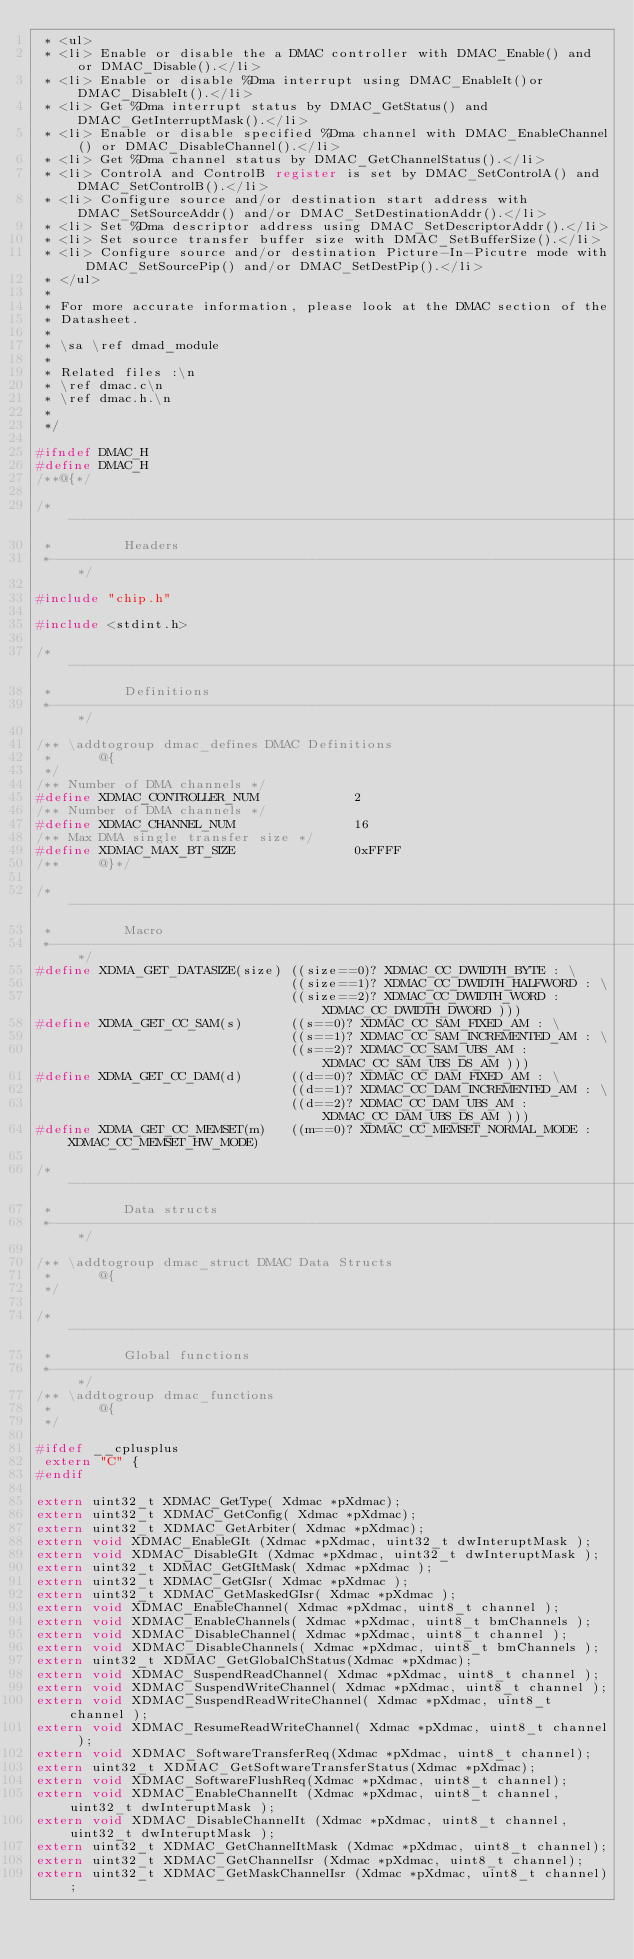Convert code to text. <code><loc_0><loc_0><loc_500><loc_500><_C_> * <ul>
 * <li> Enable or disable the a DMAC controller with DMAC_Enable() and or DMAC_Disable().</li>
 * <li> Enable or disable %Dma interrupt using DMAC_EnableIt()or DMAC_DisableIt().</li>
 * <li> Get %Dma interrupt status by DMAC_GetStatus() and DMAC_GetInterruptMask().</li>
 * <li> Enable or disable specified %Dma channel with DMAC_EnableChannel() or DMAC_DisableChannel().</li>
 * <li> Get %Dma channel status by DMAC_GetChannelStatus().</li>
 * <li> ControlA and ControlB register is set by DMAC_SetControlA() and DMAC_SetControlB().</li>
 * <li> Configure source and/or destination start address with DMAC_SetSourceAddr() and/or DMAC_SetDestinationAddr().</li>
 * <li> Set %Dma descriptor address using DMAC_SetDescriptorAddr().</li>
 * <li> Set source transfer buffer size with DMAC_SetBufferSize().</li>
 * <li> Configure source and/or destination Picture-In-Picutre mode with DMAC_SetSourcePip() and/or DMAC_SetDestPip().</li>
 * </ul>
 *
 * For more accurate information, please look at the DMAC section of the
 * Datasheet.
 *
 * \sa \ref dmad_module
 *
 * Related files :\n
 * \ref dmac.c\n
 * \ref dmac.h.\n
 *
 */

#ifndef DMAC_H
#define DMAC_H
/**@{*/

/*------------------------------------------------------------------------------
 *         Headers
 *----------------------------------------------------------------------------*/

#include "chip.h"

#include <stdint.h>

/*------------------------------------------------------------------------------
 *         Definitions
 *----------------------------------------------------------------------------*/

/** \addtogroup dmac_defines DMAC Definitions
 *      @{
 */
/** Number of DMA channels */
#define XDMAC_CONTROLLER_NUM            2
/** Number of DMA channels */
#define XDMAC_CHANNEL_NUM               16
/** Max DMA single transfer size */
#define XDMAC_MAX_BT_SIZE               0xFFFF
/**     @}*/

/*----------------------------------------------------------------------------
 *         Macro
 *----------------------------------------------------------------------------*/
#define XDMA_GET_DATASIZE(size) ((size==0)? XDMAC_CC_DWIDTH_BYTE : \
                                ((size==1)? XDMAC_CC_DWIDTH_HALFWORD : \
                                ((size==2)? XDMAC_CC_DWIDTH_WORD : XDMAC_CC_DWIDTH_DWORD )))
#define XDMA_GET_CC_SAM(s)      ((s==0)? XDMAC_CC_SAM_FIXED_AM : \
                                ((s==1)? XDMAC_CC_SAM_INCREMENTED_AM : \
                                ((s==2)? XDMAC_CC_SAM_UBS_AM : XDMAC_CC_SAM_UBS_DS_AM )))
#define XDMA_GET_CC_DAM(d)      ((d==0)? XDMAC_CC_DAM_FIXED_AM : \
                                ((d==1)? XDMAC_CC_DAM_INCREMENTED_AM : \
                                ((d==2)? XDMAC_CC_DAM_UBS_AM : XDMAC_CC_DAM_UBS_DS_AM )))
#define XDMA_GET_CC_MEMSET(m)   ((m==0)? XDMAC_CC_MEMSET_NORMAL_MODE : XDMAC_CC_MEMSET_HW_MODE)

/*------------------------------------------------------------------------------
 *         Data structs
 *----------------------------------------------------------------------------*/

/** \addtogroup dmac_struct DMAC Data Structs
 *      @{
 */

/*------------------------------------------------------------------------------
 *         Global functions
 *------------------------------------------------------------------------------*/
/** \addtogroup dmac_functions
 *      @{
 */

#ifdef __cplusplus
 extern "C" {
#endif

extern uint32_t XDMAC_GetType( Xdmac *pXdmac);
extern uint32_t XDMAC_GetConfig( Xdmac *pXdmac);
extern uint32_t XDMAC_GetArbiter( Xdmac *pXdmac);
extern void XDMAC_EnableGIt (Xdmac *pXdmac, uint32_t dwInteruptMask );
extern void XDMAC_DisableGIt (Xdmac *pXdmac, uint32_t dwInteruptMask );
extern uint32_t XDMAC_GetGItMask( Xdmac *pXdmac );
extern uint32_t XDMAC_GetGIsr( Xdmac *pXdmac );
extern uint32_t XDMAC_GetMaskedGIsr( Xdmac *pXdmac );
extern void XDMAC_EnableChannel( Xdmac *pXdmac, uint8_t channel );
extern void XDMAC_EnableChannels( Xdmac *pXdmac, uint8_t bmChannels );
extern void XDMAC_DisableChannel( Xdmac *pXdmac, uint8_t channel );
extern void XDMAC_DisableChannels( Xdmac *pXdmac, uint8_t bmChannels );
extern uint32_t XDMAC_GetGlobalChStatus(Xdmac *pXdmac);
extern void XDMAC_SuspendReadChannel( Xdmac *pXdmac, uint8_t channel );
extern void XDMAC_SuspendWriteChannel( Xdmac *pXdmac, uint8_t channel );
extern void XDMAC_SuspendReadWriteChannel( Xdmac *pXdmac, uint8_t channel );
extern void XDMAC_ResumeReadWriteChannel( Xdmac *pXdmac, uint8_t channel );
extern void XDMAC_SoftwareTransferReq(Xdmac *pXdmac, uint8_t channel);
extern uint32_t XDMAC_GetSoftwareTransferStatus(Xdmac *pXdmac);
extern void XDMAC_SoftwareFlushReq(Xdmac *pXdmac, uint8_t channel);
extern void XDMAC_EnableChannelIt (Xdmac *pXdmac, uint8_t channel, uint32_t dwInteruptMask );
extern void XDMAC_DisableChannelIt (Xdmac *pXdmac, uint8_t channel, uint32_t dwInteruptMask );
extern uint32_t XDMAC_GetChannelItMask (Xdmac *pXdmac, uint8_t channel);
extern uint32_t XDMAC_GetChannelIsr (Xdmac *pXdmac, uint8_t channel);
extern uint32_t XDMAC_GetMaskChannelIsr (Xdmac *pXdmac, uint8_t channel);</code> 